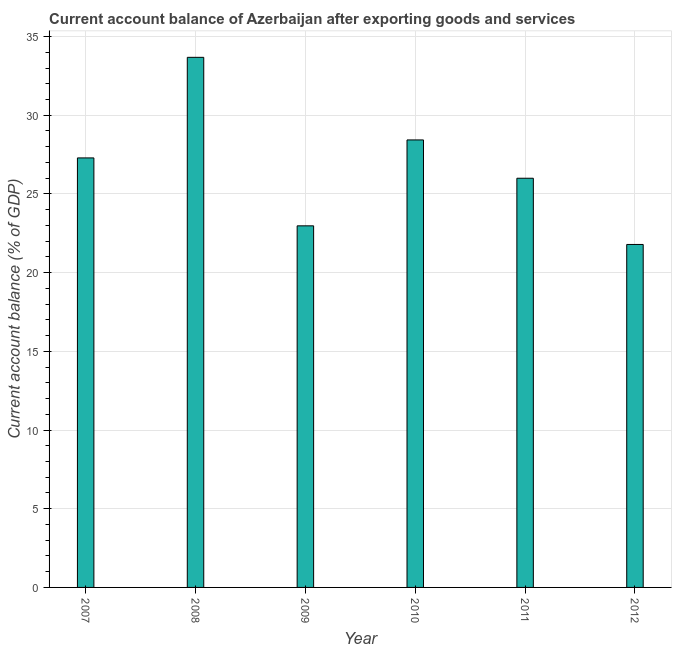Does the graph contain grids?
Offer a very short reply. Yes. What is the title of the graph?
Your answer should be very brief. Current account balance of Azerbaijan after exporting goods and services. What is the label or title of the Y-axis?
Give a very brief answer. Current account balance (% of GDP). What is the current account balance in 2009?
Give a very brief answer. 22.97. Across all years, what is the maximum current account balance?
Keep it short and to the point. 33.68. Across all years, what is the minimum current account balance?
Offer a terse response. 21.79. In which year was the current account balance minimum?
Give a very brief answer. 2012. What is the sum of the current account balance?
Give a very brief answer. 160.16. What is the difference between the current account balance in 2008 and 2011?
Your response must be concise. 7.68. What is the average current account balance per year?
Ensure brevity in your answer.  26.69. What is the median current account balance?
Ensure brevity in your answer.  26.64. In how many years, is the current account balance greater than 21 %?
Your answer should be compact. 6. Do a majority of the years between 2011 and 2010 (inclusive) have current account balance greater than 14 %?
Make the answer very short. No. What is the ratio of the current account balance in 2007 to that in 2009?
Your answer should be very brief. 1.19. Is the difference between the current account balance in 2011 and 2012 greater than the difference between any two years?
Provide a succinct answer. No. What is the difference between the highest and the second highest current account balance?
Ensure brevity in your answer.  5.25. What is the difference between the highest and the lowest current account balance?
Give a very brief answer. 11.89. How many bars are there?
Your answer should be very brief. 6. What is the difference between two consecutive major ticks on the Y-axis?
Give a very brief answer. 5. What is the Current account balance (% of GDP) in 2007?
Ensure brevity in your answer.  27.29. What is the Current account balance (% of GDP) in 2008?
Your answer should be very brief. 33.68. What is the Current account balance (% of GDP) of 2009?
Your answer should be compact. 22.97. What is the Current account balance (% of GDP) of 2010?
Your answer should be very brief. 28.43. What is the Current account balance (% of GDP) of 2011?
Your answer should be compact. 26. What is the Current account balance (% of GDP) of 2012?
Give a very brief answer. 21.79. What is the difference between the Current account balance (% of GDP) in 2007 and 2008?
Offer a very short reply. -6.39. What is the difference between the Current account balance (% of GDP) in 2007 and 2009?
Keep it short and to the point. 4.32. What is the difference between the Current account balance (% of GDP) in 2007 and 2010?
Offer a very short reply. -1.14. What is the difference between the Current account balance (% of GDP) in 2007 and 2011?
Provide a succinct answer. 1.29. What is the difference between the Current account balance (% of GDP) in 2007 and 2012?
Your response must be concise. 5.5. What is the difference between the Current account balance (% of GDP) in 2008 and 2009?
Your answer should be very brief. 10.71. What is the difference between the Current account balance (% of GDP) in 2008 and 2010?
Make the answer very short. 5.25. What is the difference between the Current account balance (% of GDP) in 2008 and 2011?
Your answer should be compact. 7.68. What is the difference between the Current account balance (% of GDP) in 2008 and 2012?
Provide a succinct answer. 11.89. What is the difference between the Current account balance (% of GDP) in 2009 and 2010?
Your answer should be compact. -5.46. What is the difference between the Current account balance (% of GDP) in 2009 and 2011?
Provide a short and direct response. -3.02. What is the difference between the Current account balance (% of GDP) in 2009 and 2012?
Keep it short and to the point. 1.18. What is the difference between the Current account balance (% of GDP) in 2010 and 2011?
Offer a terse response. 2.43. What is the difference between the Current account balance (% of GDP) in 2010 and 2012?
Your answer should be compact. 6.64. What is the difference between the Current account balance (% of GDP) in 2011 and 2012?
Ensure brevity in your answer.  4.21. What is the ratio of the Current account balance (% of GDP) in 2007 to that in 2008?
Make the answer very short. 0.81. What is the ratio of the Current account balance (% of GDP) in 2007 to that in 2009?
Offer a very short reply. 1.19. What is the ratio of the Current account balance (% of GDP) in 2007 to that in 2010?
Offer a terse response. 0.96. What is the ratio of the Current account balance (% of GDP) in 2007 to that in 2011?
Give a very brief answer. 1.05. What is the ratio of the Current account balance (% of GDP) in 2007 to that in 2012?
Offer a very short reply. 1.25. What is the ratio of the Current account balance (% of GDP) in 2008 to that in 2009?
Offer a terse response. 1.47. What is the ratio of the Current account balance (% of GDP) in 2008 to that in 2010?
Provide a short and direct response. 1.19. What is the ratio of the Current account balance (% of GDP) in 2008 to that in 2011?
Your response must be concise. 1.3. What is the ratio of the Current account balance (% of GDP) in 2008 to that in 2012?
Provide a succinct answer. 1.55. What is the ratio of the Current account balance (% of GDP) in 2009 to that in 2010?
Offer a very short reply. 0.81. What is the ratio of the Current account balance (% of GDP) in 2009 to that in 2011?
Your answer should be very brief. 0.88. What is the ratio of the Current account balance (% of GDP) in 2009 to that in 2012?
Your response must be concise. 1.05. What is the ratio of the Current account balance (% of GDP) in 2010 to that in 2011?
Your response must be concise. 1.09. What is the ratio of the Current account balance (% of GDP) in 2010 to that in 2012?
Keep it short and to the point. 1.3. What is the ratio of the Current account balance (% of GDP) in 2011 to that in 2012?
Offer a very short reply. 1.19. 